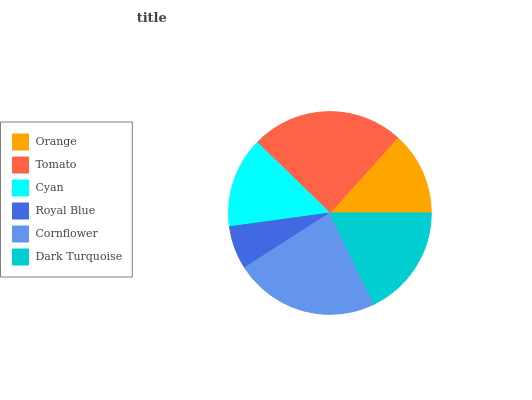Is Royal Blue the minimum?
Answer yes or no. Yes. Is Tomato the maximum?
Answer yes or no. Yes. Is Cyan the minimum?
Answer yes or no. No. Is Cyan the maximum?
Answer yes or no. No. Is Tomato greater than Cyan?
Answer yes or no. Yes. Is Cyan less than Tomato?
Answer yes or no. Yes. Is Cyan greater than Tomato?
Answer yes or no. No. Is Tomato less than Cyan?
Answer yes or no. No. Is Dark Turquoise the high median?
Answer yes or no. Yes. Is Cyan the low median?
Answer yes or no. Yes. Is Cyan the high median?
Answer yes or no. No. Is Dark Turquoise the low median?
Answer yes or no. No. 